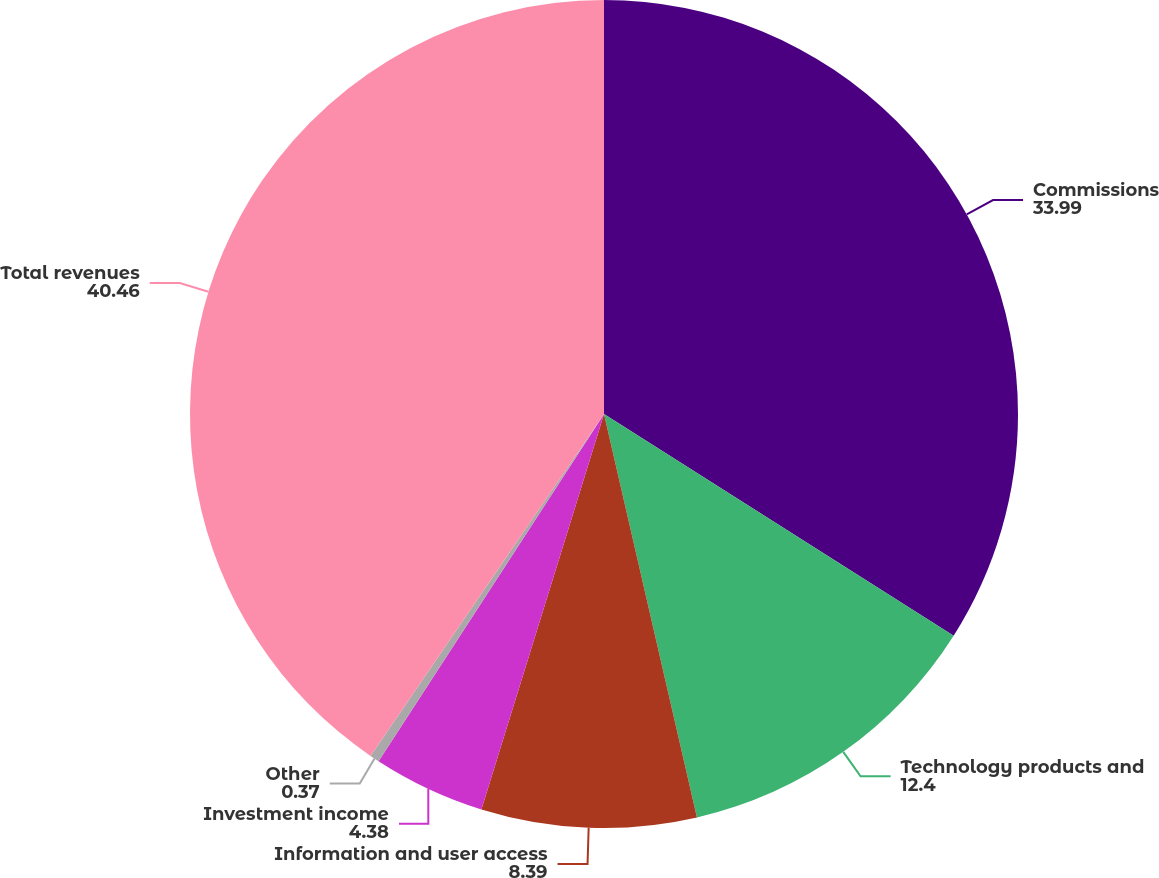Convert chart. <chart><loc_0><loc_0><loc_500><loc_500><pie_chart><fcel>Commissions<fcel>Technology products and<fcel>Information and user access<fcel>Investment income<fcel>Other<fcel>Total revenues<nl><fcel>33.99%<fcel>12.4%<fcel>8.39%<fcel>4.38%<fcel>0.37%<fcel>40.46%<nl></chart> 